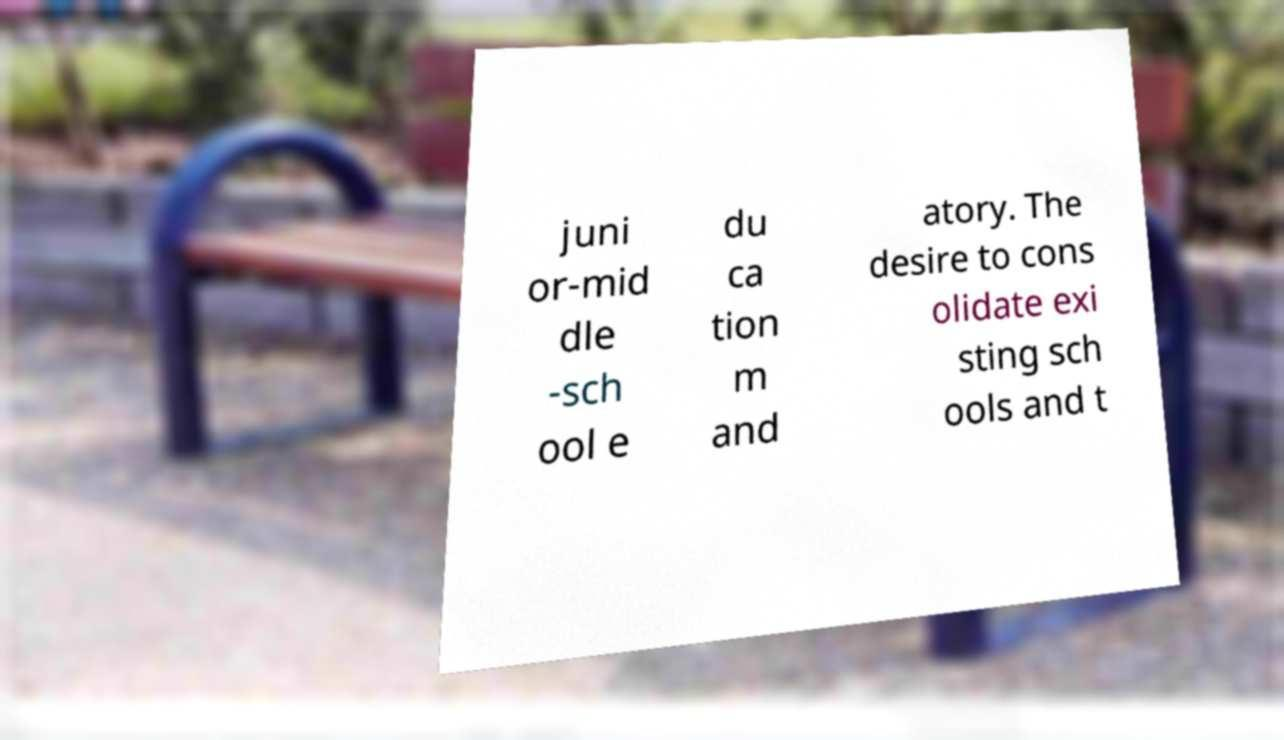There's text embedded in this image that I need extracted. Can you transcribe it verbatim? juni or-mid dle -sch ool e du ca tion m and atory. The desire to cons olidate exi sting sch ools and t 